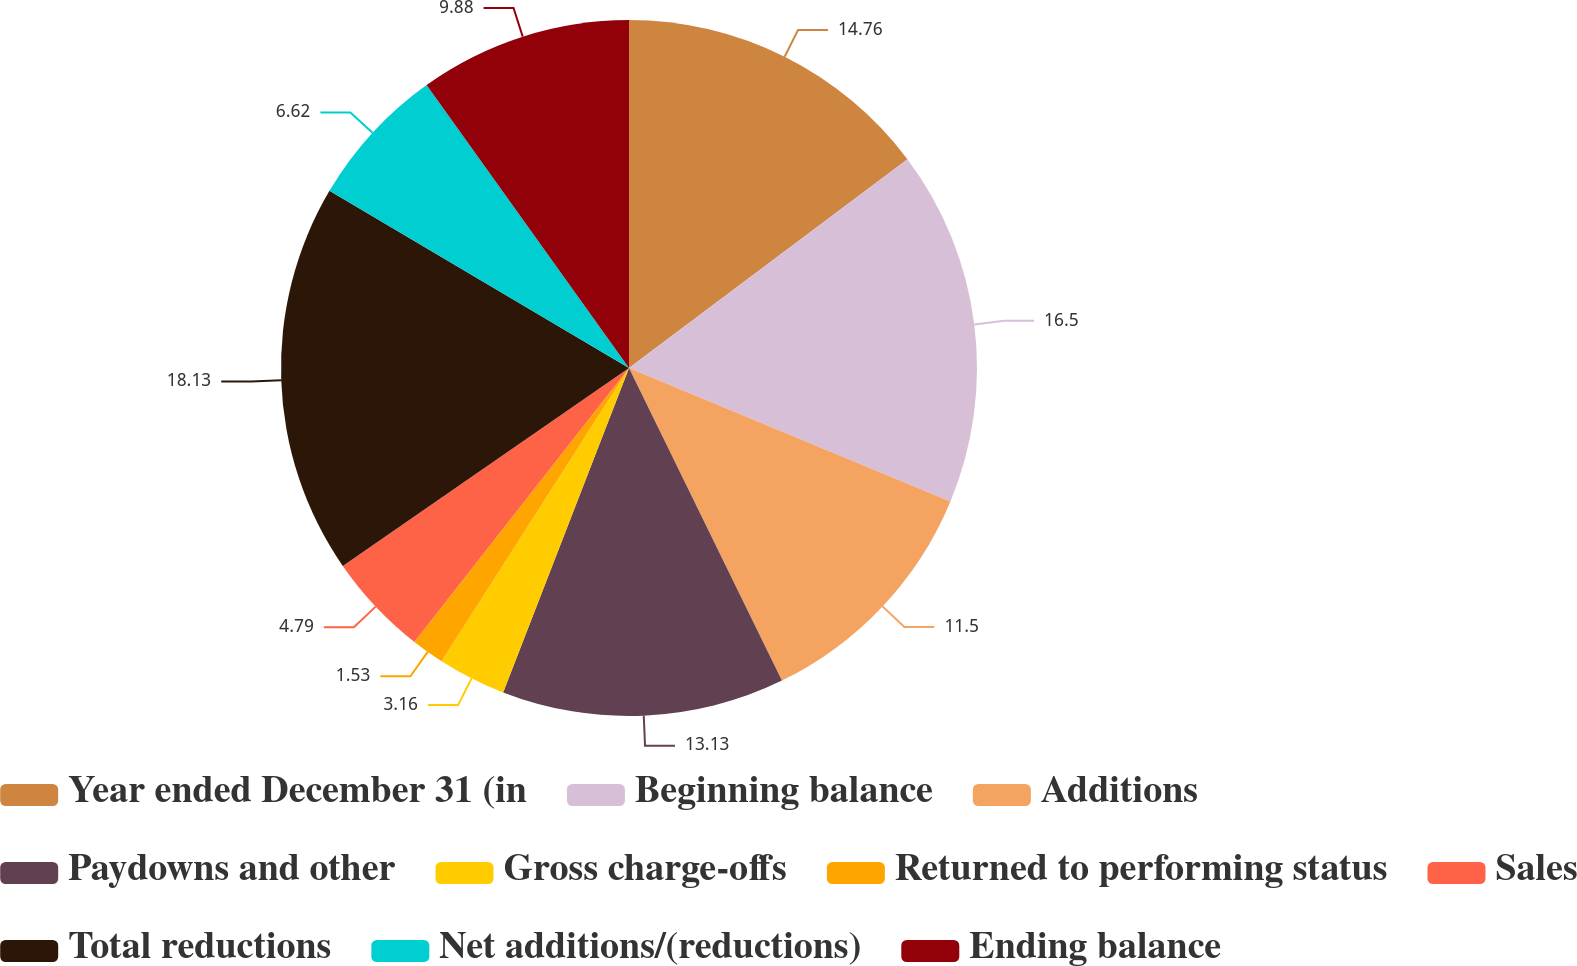Convert chart to OTSL. <chart><loc_0><loc_0><loc_500><loc_500><pie_chart><fcel>Year ended December 31 (in<fcel>Beginning balance<fcel>Additions<fcel>Paydowns and other<fcel>Gross charge-offs<fcel>Returned to performing status<fcel>Sales<fcel>Total reductions<fcel>Net additions/(reductions)<fcel>Ending balance<nl><fcel>14.76%<fcel>16.5%<fcel>11.5%<fcel>13.13%<fcel>3.16%<fcel>1.53%<fcel>4.79%<fcel>18.13%<fcel>6.62%<fcel>9.88%<nl></chart> 